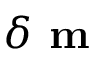Convert formula to latex. <formula><loc_0><loc_0><loc_500><loc_500>\delta m</formula> 